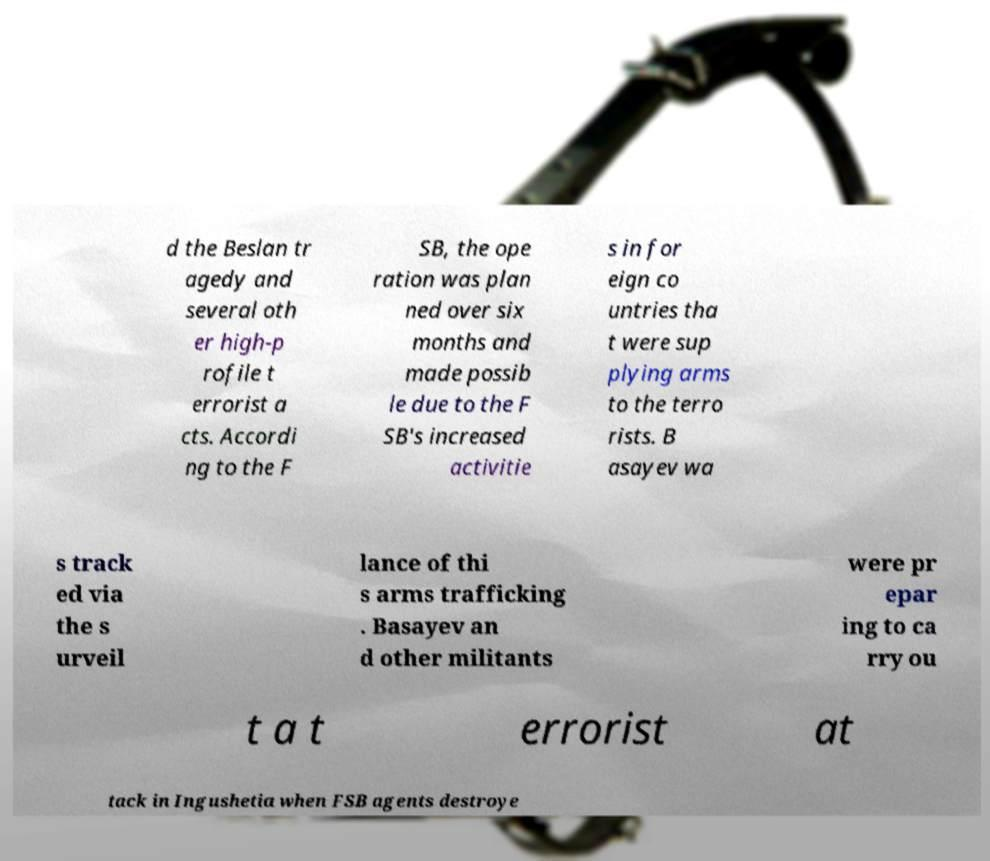For documentation purposes, I need the text within this image transcribed. Could you provide that? d the Beslan tr agedy and several oth er high-p rofile t errorist a cts. Accordi ng to the F SB, the ope ration was plan ned over six months and made possib le due to the F SB's increased activitie s in for eign co untries tha t were sup plying arms to the terro rists. B asayev wa s track ed via the s urveil lance of thi s arms trafficking . Basayev an d other militants were pr epar ing to ca rry ou t a t errorist at tack in Ingushetia when FSB agents destroye 